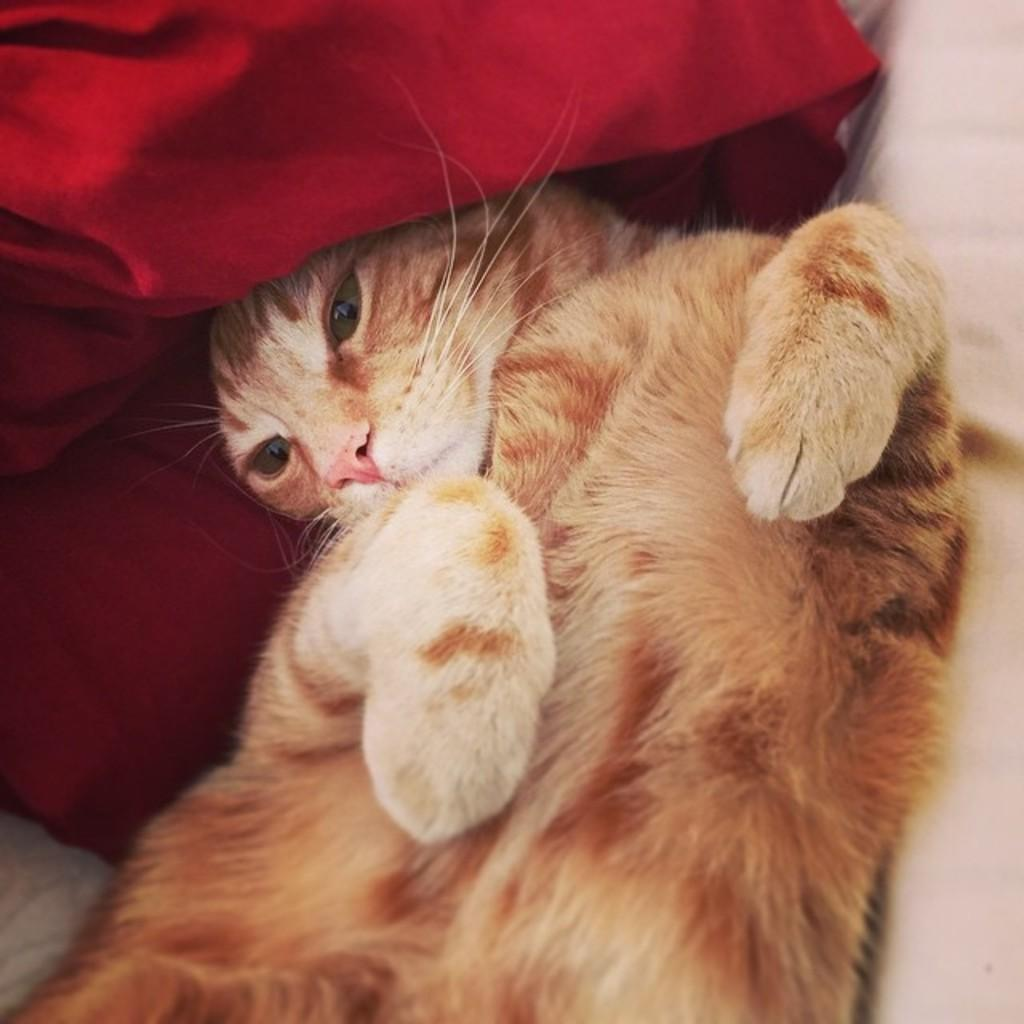What type of animal is in the image? There is a cat in the image. What color is the cloth behind the cat? The cloth behind the cat is red. Can you describe the object on the right side of the image? There is an object on the right side of the image that looks like a table. What industry is the cat working in within the image? There is no indication of an industry or job within the image; it simply shows a cat with a red cloth behind it and an object that resembles a table. 